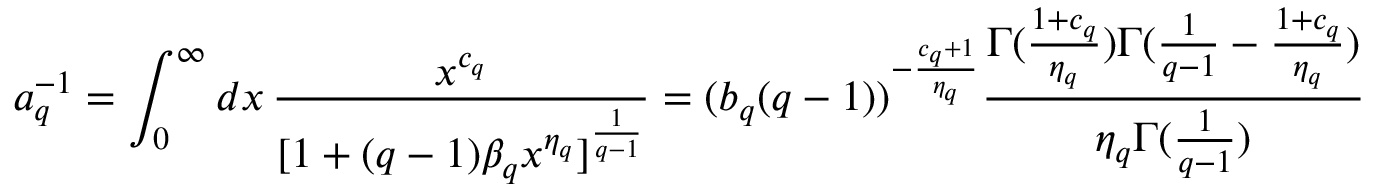<formula> <loc_0><loc_0><loc_500><loc_500>a _ { q } ^ { - 1 } = \int _ { 0 } ^ { \infty } d x \, \frac { x ^ { c _ { q } } } { [ 1 + ( q - 1 ) \beta _ { q } x ^ { \eta _ { q } } ] ^ { \frac { 1 } { q - 1 } } } = ( b _ { q } ( q - 1 ) ) ^ { - \frac { c _ { q } + 1 } { \eta _ { q } } } \frac { \Gamma ( \frac { 1 + c _ { q } } { \eta _ { q } } ) \Gamma ( \frac { 1 } { q - 1 } - \frac { 1 + c _ { q } } { \eta _ { q } } ) } { \eta _ { q } \Gamma ( \frac { 1 } { q - 1 } ) }</formula> 